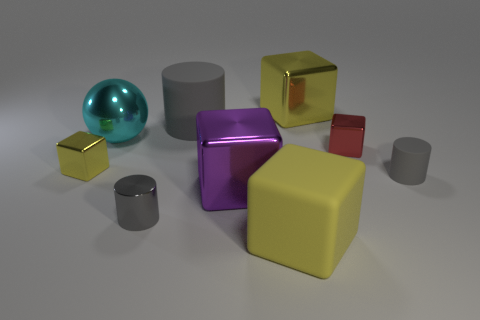Subtract all tiny cylinders. How many cylinders are left? 1 Subtract all red cylinders. How many yellow blocks are left? 3 Subtract all red cubes. How many cubes are left? 4 Add 1 small yellow cubes. How many objects exist? 10 Subtract 3 blocks. How many blocks are left? 2 Subtract all yellow cylinders. Subtract all brown cubes. How many cylinders are left? 3 Add 7 large blue rubber cylinders. How many large blue rubber cylinders exist? 7 Subtract 0 purple cylinders. How many objects are left? 9 Subtract all cubes. How many objects are left? 4 Subtract all things. Subtract all large blue cylinders. How many objects are left? 0 